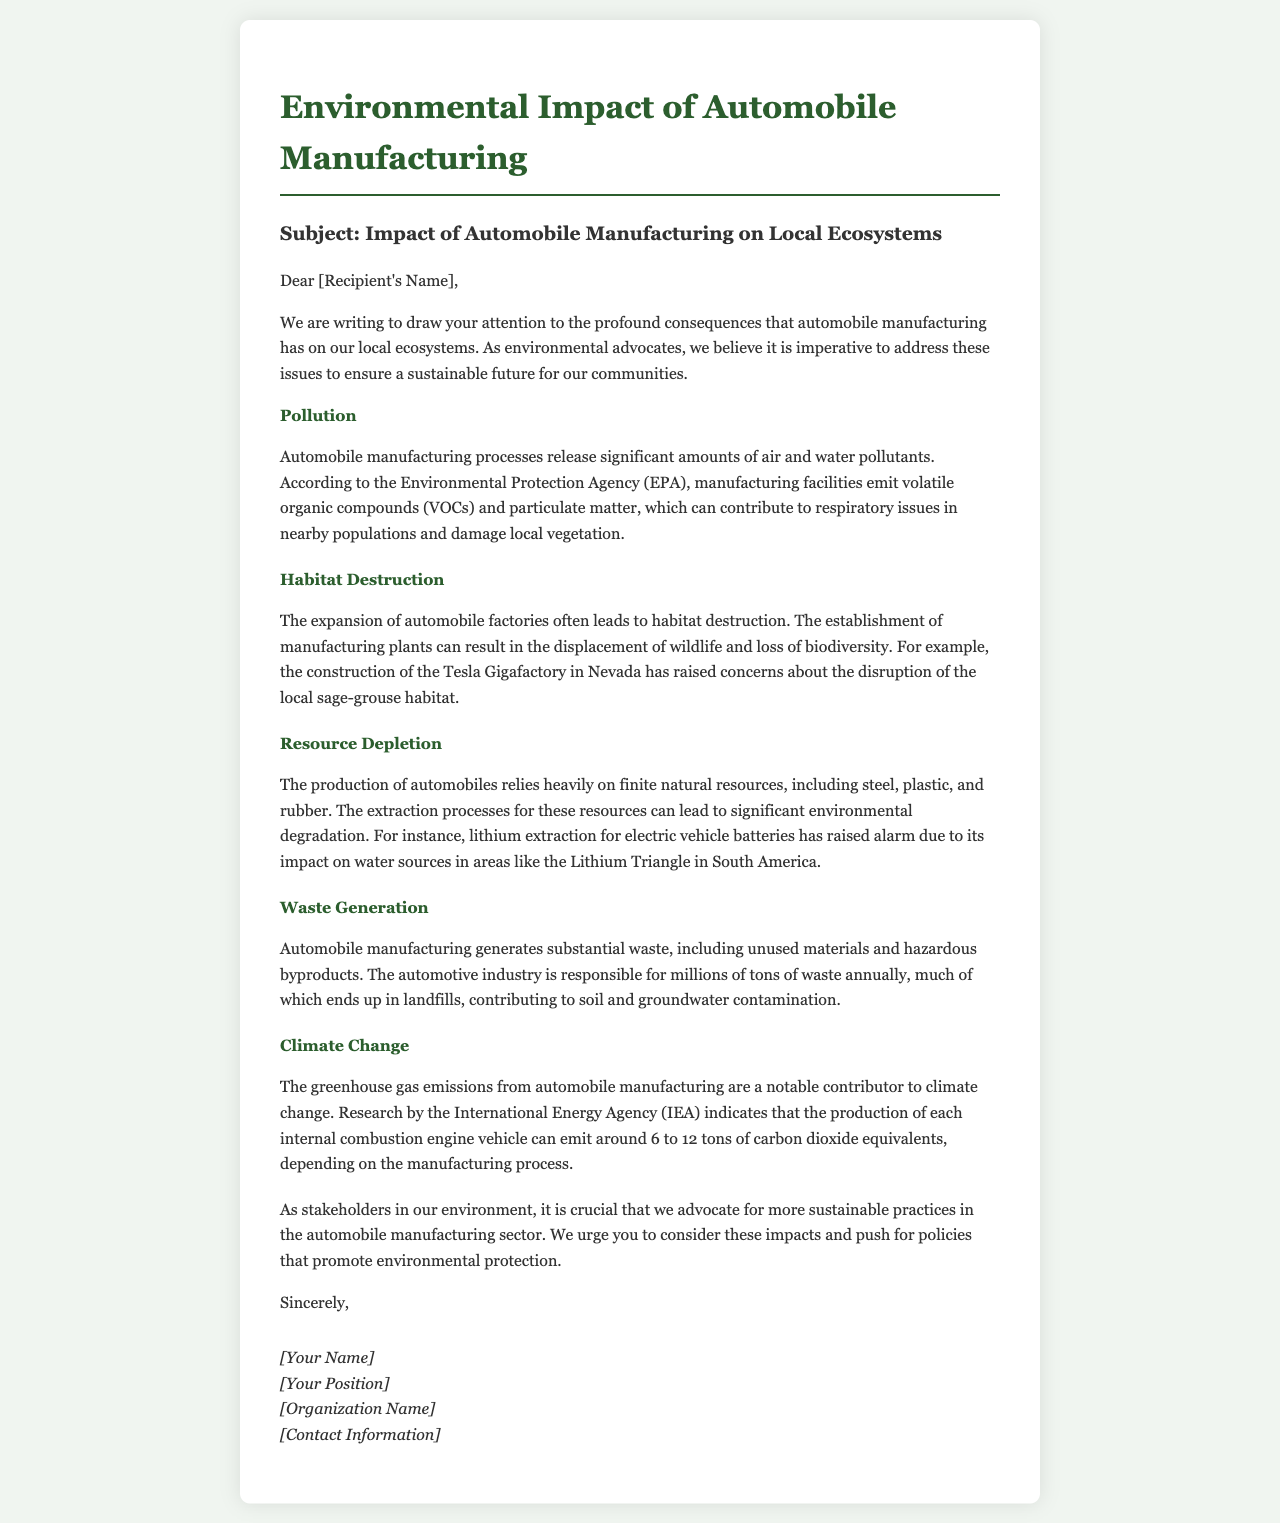What is the subject of the letter? The subject is explicitly stated in the document as "Impact of Automobile Manufacturing on Local Ecosystems."
Answer: Impact of Automobile Manufacturing on Local Ecosystems What pollutants are emitted from automobile manufacturing? The pollutants mentioned in the document include volatile organic compounds (VOCs) and particulate matter.
Answer: VOCs and particulate matter Which wildlife is specifically mentioned in relation to habitat destruction? The document refers to the local sage-grouse habitat being disrupted due to the construction of the Tesla Gigafactory.
Answer: sage-grouse How many tons of carbon dioxide equivalents are emitted per internal combustion engine vehicle? According to the document, the production emits around 6 to 12 tons of carbon dioxide equivalents per vehicle.
Answer: 6 to 12 tons What is a significant consequence of lithium extraction for electric vehicle batteries? The letter states that lithium extraction impacts water sources, particularly in the Lithium Triangle in South America.
Answer: water sources What kind of waste does automobile manufacturing generate? The document mentions substantial waste, including unused materials and hazardous byproducts.
Answer: unused materials and hazardous byproducts Which organization is addressed in the letter? The letter is addressed to an unspecified recipient, which should be recognized as a stakeholder in the environment.
Answer: [Recipient's Name] What type of actions are urged in the letter? The letter advocates for more sustainable practices and policies to protect the environment.
Answer: sustainable practices and policies 